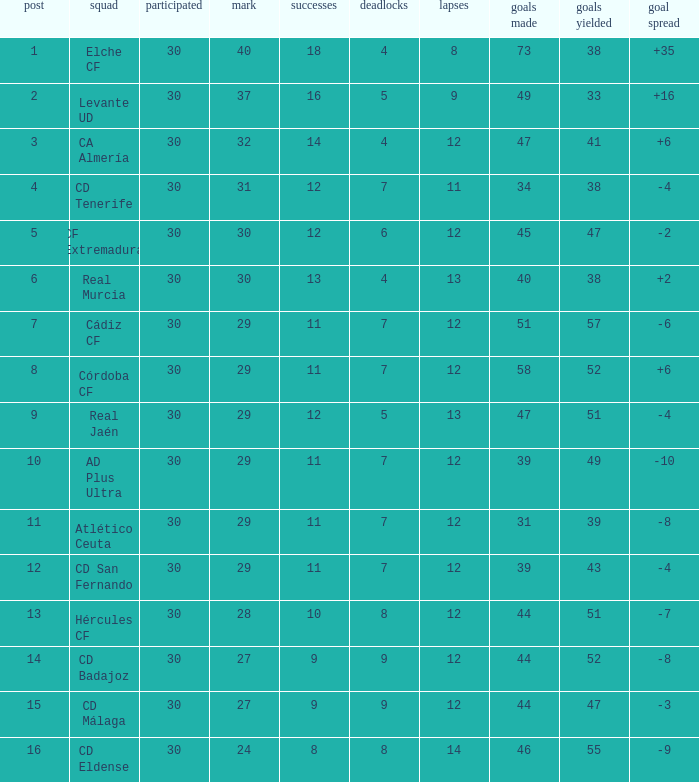What is the total number of losses with less than 73 goals for, less than 11 wins, more than 24 points, and a position greater than 15? 0.0. 